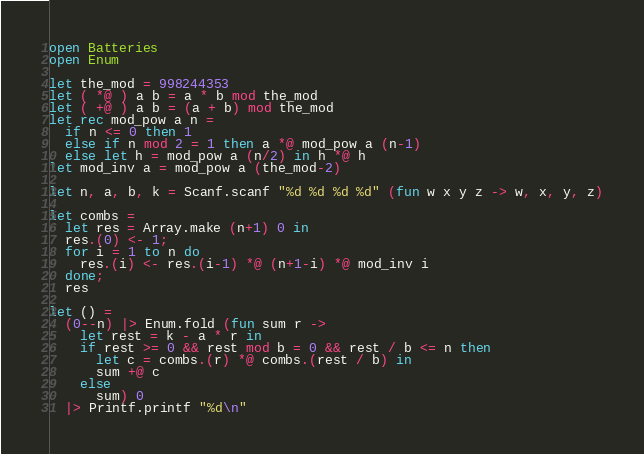Convert code to text. <code><loc_0><loc_0><loc_500><loc_500><_OCaml_>open Batteries
open Enum

let the_mod = 998244353
let ( *@ ) a b = a * b mod the_mod
let ( +@ ) a b = (a + b) mod the_mod
let rec mod_pow a n =
  if n <= 0 then 1
  else if n mod 2 = 1 then a *@ mod_pow a (n-1)
  else let h = mod_pow a (n/2) in h *@ h
let mod_inv a = mod_pow a (the_mod-2)

let n, a, b, k = Scanf.scanf "%d %d %d %d" (fun w x y z -> w, x, y, z)

let combs =
  let res = Array.make (n+1) 0 in
  res.(0) <- 1;
  for i = 1 to n do
    res.(i) <- res.(i-1) *@ (n+1-i) *@ mod_inv i
  done;
  res

let () =
  (0--n) |> Enum.fold (fun sum r ->
    let rest = k - a * r in
    if rest >= 0 && rest mod b = 0 && rest / b <= n then
      let c = combs.(r) *@ combs.(rest / b) in
      sum +@ c
    else
      sum) 0
  |> Printf.printf "%d\n"
</code> 